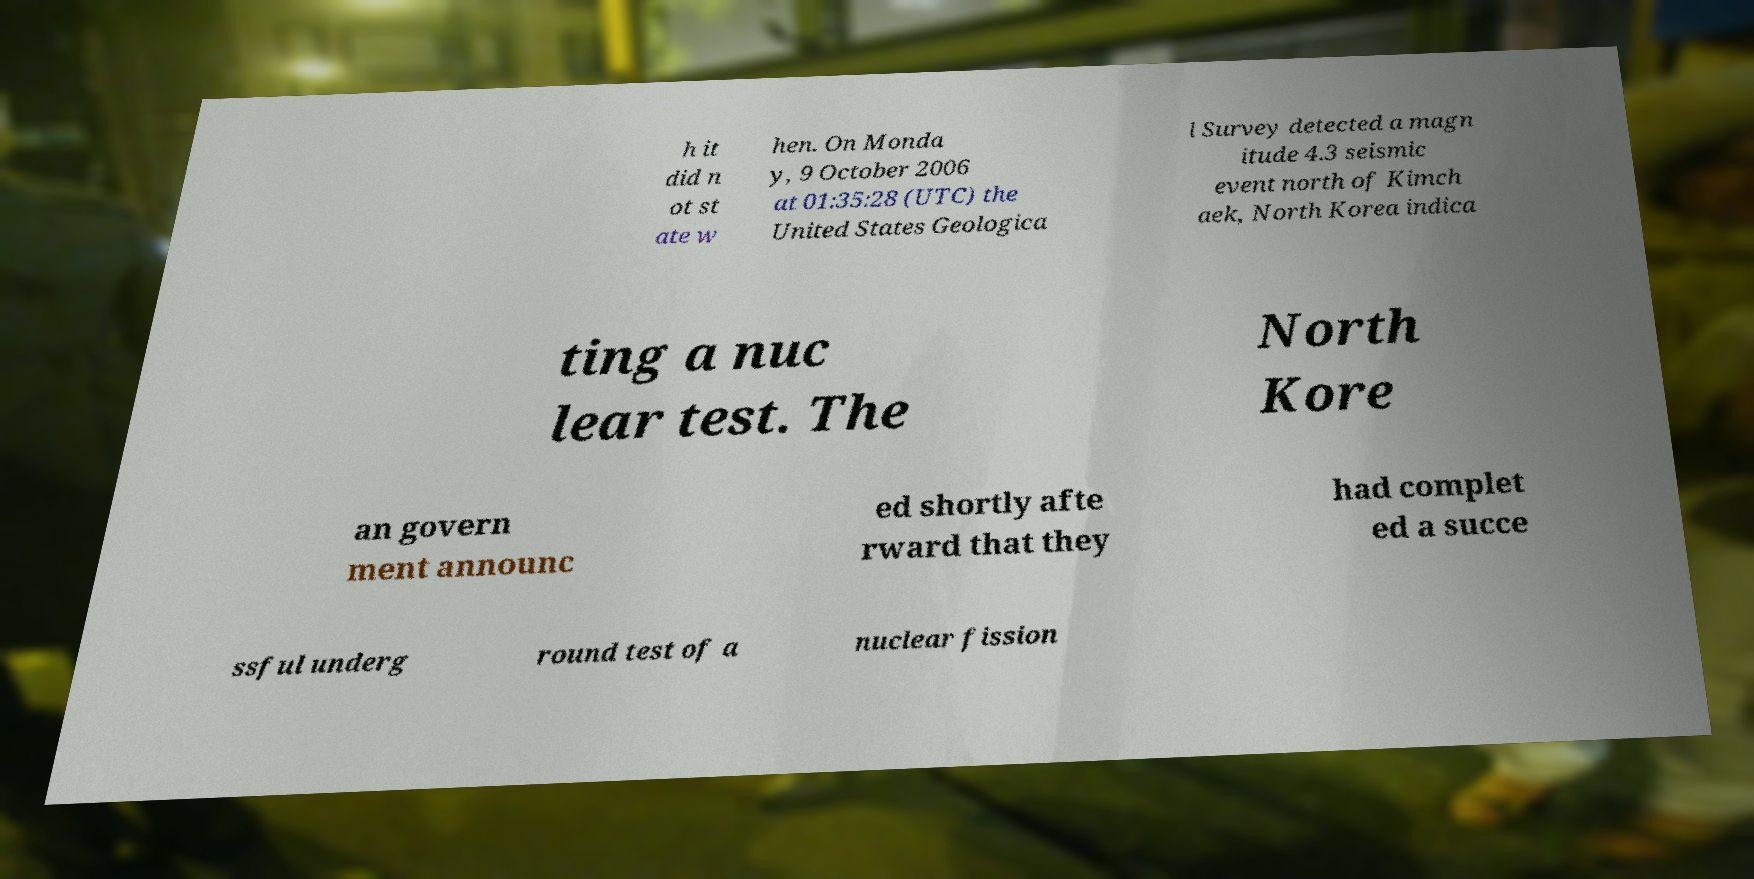I need the written content from this picture converted into text. Can you do that? h it did n ot st ate w hen. On Monda y, 9 October 2006 at 01:35:28 (UTC) the United States Geologica l Survey detected a magn itude 4.3 seismic event north of Kimch aek, North Korea indica ting a nuc lear test. The North Kore an govern ment announc ed shortly afte rward that they had complet ed a succe ssful underg round test of a nuclear fission 